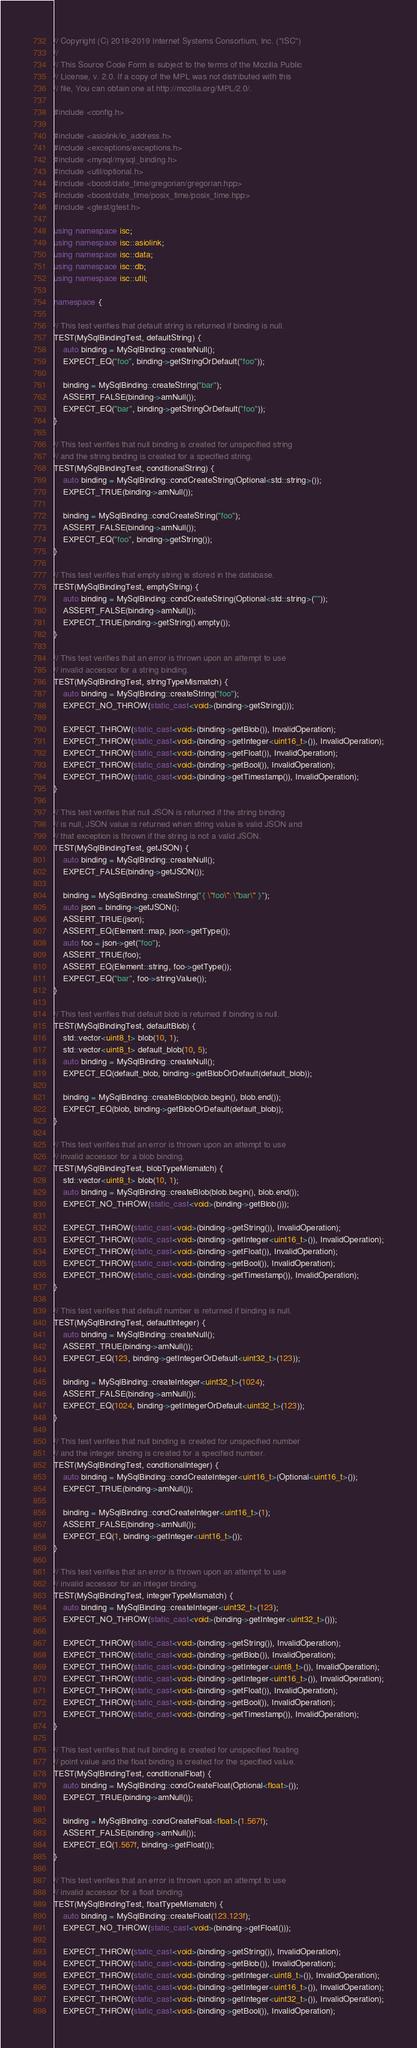<code> <loc_0><loc_0><loc_500><loc_500><_C++_>// Copyright (C) 2018-2019 Internet Systems Consortium, Inc. ("ISC")
//
// This Source Code Form is subject to the terms of the Mozilla Public
// License, v. 2.0. If a copy of the MPL was not distributed with this
// file, You can obtain one at http://mozilla.org/MPL/2.0/.

#include <config.h>

#include <asiolink/io_address.h>
#include <exceptions/exceptions.h>
#include <mysql/mysql_binding.h>
#include <util/optional.h>
#include <boost/date_time/gregorian/gregorian.hpp>
#include <boost/date_time/posix_time/posix_time.hpp>
#include <gtest/gtest.h>

using namespace isc;
using namespace isc::asiolink;
using namespace isc::data;
using namespace isc::db;
using namespace isc::util;

namespace {

// This test verifies that default string is returned if binding is null.
TEST(MySqlBindingTest, defaultString) {
    auto binding = MySqlBinding::createNull();
    EXPECT_EQ("foo", binding->getStringOrDefault("foo"));

    binding = MySqlBinding::createString("bar");
    ASSERT_FALSE(binding->amNull());
    EXPECT_EQ("bar", binding->getStringOrDefault("foo"));
}

// This test verifies that null binding is created for unspecified string
// and the string binding is created for a specified string.
TEST(MySqlBindingTest, conditionalString) {
    auto binding = MySqlBinding::condCreateString(Optional<std::string>());
    EXPECT_TRUE(binding->amNull());

    binding = MySqlBinding::condCreateString("foo");
    ASSERT_FALSE(binding->amNull());
    EXPECT_EQ("foo", binding->getString());
}

// This test verifies that empty string is stored in the database.
TEST(MySqlBindingTest, emptyString) {
    auto binding = MySqlBinding::condCreateString(Optional<std::string>(""));
    ASSERT_FALSE(binding->amNull());
    EXPECT_TRUE(binding->getString().empty());
}

// This test verifies that an error is thrown upon an attempt to use
// invalid accessor for a string binding.
TEST(MySqlBindingTest, stringTypeMismatch) {
    auto binding = MySqlBinding::createString("foo");
    EXPECT_NO_THROW(static_cast<void>(binding->getString()));

    EXPECT_THROW(static_cast<void>(binding->getBlob()), InvalidOperation);
    EXPECT_THROW(static_cast<void>(binding->getInteger<uint16_t>()), InvalidOperation);
    EXPECT_THROW(static_cast<void>(binding->getFloat()), InvalidOperation);
    EXPECT_THROW(static_cast<void>(binding->getBool()), InvalidOperation);
    EXPECT_THROW(static_cast<void>(binding->getTimestamp()), InvalidOperation);
}

// This test verifies that null JSON is returned if the string binding
// is null, JSON value is returned when string value is valid JSON and
// that exception is thrown if the string is not a valid JSON.
TEST(MySqlBindingTest, getJSON) {
    auto binding = MySqlBinding::createNull();
    EXPECT_FALSE(binding->getJSON());

    binding = MySqlBinding::createString("{ \"foo\": \"bar\" }");
    auto json = binding->getJSON();
    ASSERT_TRUE(json);
    ASSERT_EQ(Element::map, json->getType());
    auto foo = json->get("foo");
    ASSERT_TRUE(foo);
    ASSERT_EQ(Element::string, foo->getType());
    EXPECT_EQ("bar", foo->stringValue());
}

// This test verifies that default blob is returned if binding is null.
TEST(MySqlBindingTest, defaultBlob) {
    std::vector<uint8_t> blob(10, 1);
    std::vector<uint8_t> default_blob(10, 5);
    auto binding = MySqlBinding::createNull();
    EXPECT_EQ(default_blob, binding->getBlobOrDefault(default_blob));

    binding = MySqlBinding::createBlob(blob.begin(), blob.end());
    EXPECT_EQ(blob, binding->getBlobOrDefault(default_blob));
}

// This test verifies that an error is thrown upon an attempt to use
// invalid accessor for a blob binding.
TEST(MySqlBindingTest, blobTypeMismatch) {
    std::vector<uint8_t> blob(10, 1);
    auto binding = MySqlBinding::createBlob(blob.begin(), blob.end());
    EXPECT_NO_THROW(static_cast<void>(binding->getBlob()));

    EXPECT_THROW(static_cast<void>(binding->getString()), InvalidOperation);
    EXPECT_THROW(static_cast<void>(binding->getInteger<uint16_t>()), InvalidOperation);
    EXPECT_THROW(static_cast<void>(binding->getFloat()), InvalidOperation);
    EXPECT_THROW(static_cast<void>(binding->getBool()), InvalidOperation);
    EXPECT_THROW(static_cast<void>(binding->getTimestamp()), InvalidOperation);
}

// This test verifies that default number is returned if binding is null.
TEST(MySqlBindingTest, defaultInteger) {
    auto binding = MySqlBinding::createNull();
    ASSERT_TRUE(binding->amNull());
    EXPECT_EQ(123, binding->getIntegerOrDefault<uint32_t>(123));

    binding = MySqlBinding::createInteger<uint32_t>(1024);
    ASSERT_FALSE(binding->amNull());
    EXPECT_EQ(1024, binding->getIntegerOrDefault<uint32_t>(123));
}

// This test verifies that null binding is created for unspecified number
// and the integer binding is created for a specified number.
TEST(MySqlBindingTest, conditionalInteger) {
    auto binding = MySqlBinding::condCreateInteger<uint16_t>(Optional<uint16_t>());
    EXPECT_TRUE(binding->amNull());

    binding = MySqlBinding::condCreateInteger<uint16_t>(1);
    ASSERT_FALSE(binding->amNull());
    EXPECT_EQ(1, binding->getInteger<uint16_t>());
}

// This test verifies that an error is thrown upon an attempt to use
// invalid accessor for an integer binding.
TEST(MySqlBindingTest, integerTypeMismatch) {
    auto binding = MySqlBinding::createInteger<uint32_t>(123);
    EXPECT_NO_THROW(static_cast<void>(binding->getInteger<uint32_t>()));

    EXPECT_THROW(static_cast<void>(binding->getString()), InvalidOperation);
    EXPECT_THROW(static_cast<void>(binding->getBlob()), InvalidOperation);
    EXPECT_THROW(static_cast<void>(binding->getInteger<uint8_t>()), InvalidOperation);
    EXPECT_THROW(static_cast<void>(binding->getInteger<uint16_t>()), InvalidOperation);
    EXPECT_THROW(static_cast<void>(binding->getFloat()), InvalidOperation);
    EXPECT_THROW(static_cast<void>(binding->getBool()), InvalidOperation);
    EXPECT_THROW(static_cast<void>(binding->getTimestamp()), InvalidOperation);
}

// This test verifies that null binding is created for unspecified floating
// point value and the float binding is created for the specified value.
TEST(MySqlBindingTest, conditionalFloat) {
    auto binding = MySqlBinding::condCreateFloat(Optional<float>());
    EXPECT_TRUE(binding->amNull());

    binding = MySqlBinding::condCreateFloat<float>(1.567f);
    ASSERT_FALSE(binding->amNull());
    EXPECT_EQ(1.567f, binding->getFloat());
}

// This test verifies that an error is thrown upon an attempt to use
// invalid accessor for a float binding.
TEST(MySqlBindingTest, floatTypeMismatch) {
    auto binding = MySqlBinding::createFloat(123.123f);
    EXPECT_NO_THROW(static_cast<void>(binding->getFloat()));

    EXPECT_THROW(static_cast<void>(binding->getString()), InvalidOperation);
    EXPECT_THROW(static_cast<void>(binding->getBlob()), InvalidOperation);
    EXPECT_THROW(static_cast<void>(binding->getInteger<uint8_t>()), InvalidOperation);
    EXPECT_THROW(static_cast<void>(binding->getInteger<uint16_t>()), InvalidOperation);
    EXPECT_THROW(static_cast<void>(binding->getInteger<uint32_t>()), InvalidOperation);
    EXPECT_THROW(static_cast<void>(binding->getBool()), InvalidOperation);</code> 